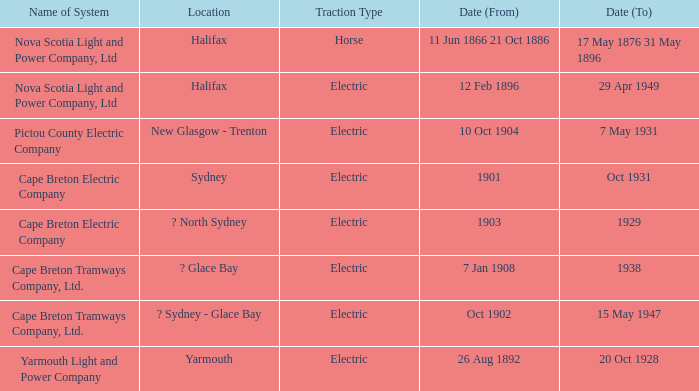On which date is a traction type of electric connected with the yarmouth light and power company system? 20 Oct 1928. 